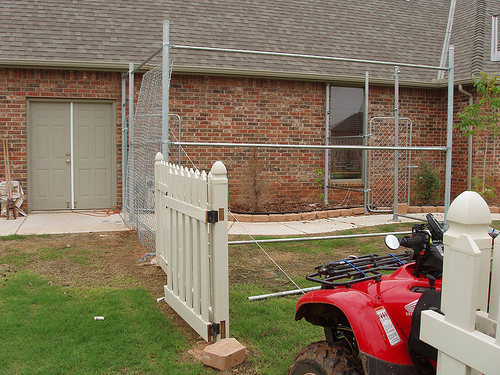<image>
Can you confirm if the vehicle is next to the fence? Yes. The vehicle is positioned adjacent to the fence, located nearby in the same general area. 